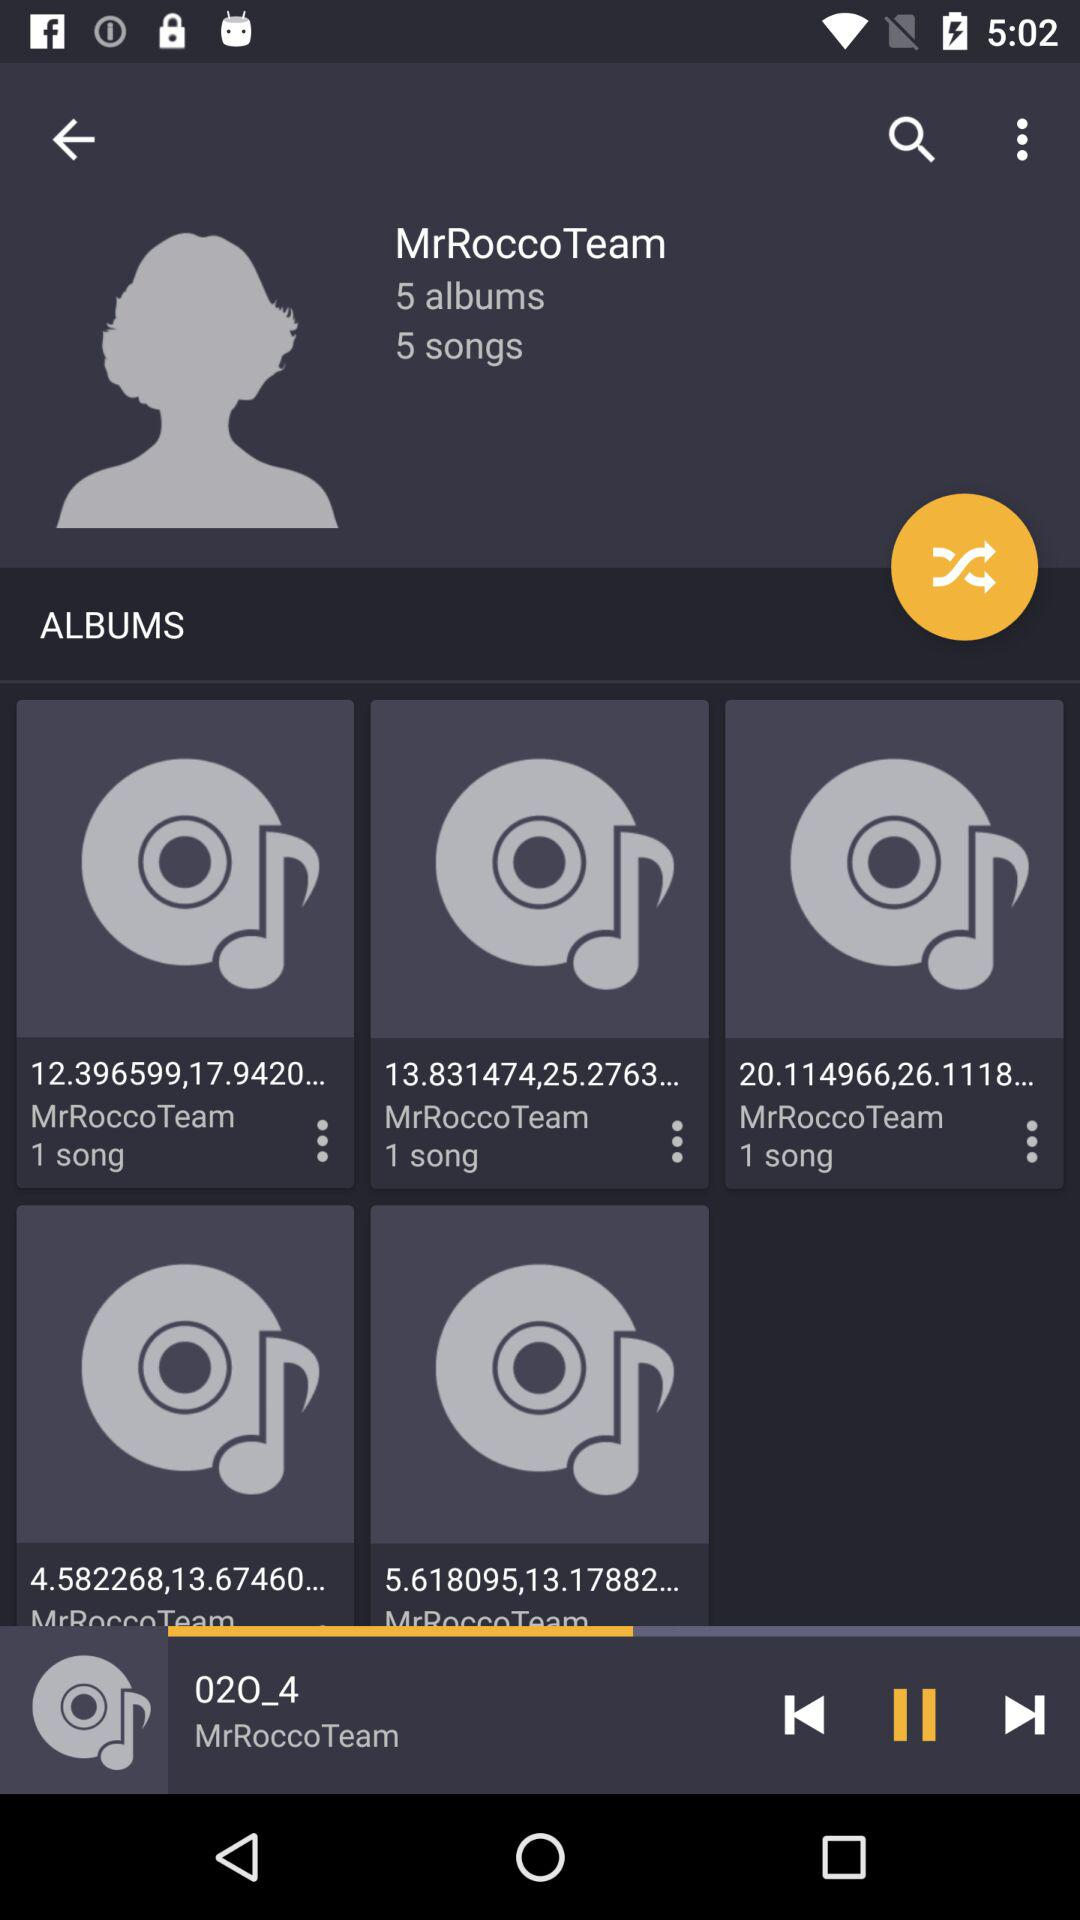What is the name of team?
When the provided information is insufficient, respond with <no answer>. <no answer> 